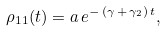Convert formula to latex. <formula><loc_0><loc_0><loc_500><loc_500>\rho _ { 1 1 } ( t ) = a \, e ^ { - \, ( \gamma \, + \, \gamma _ { 2 } ) \, t } ,</formula> 